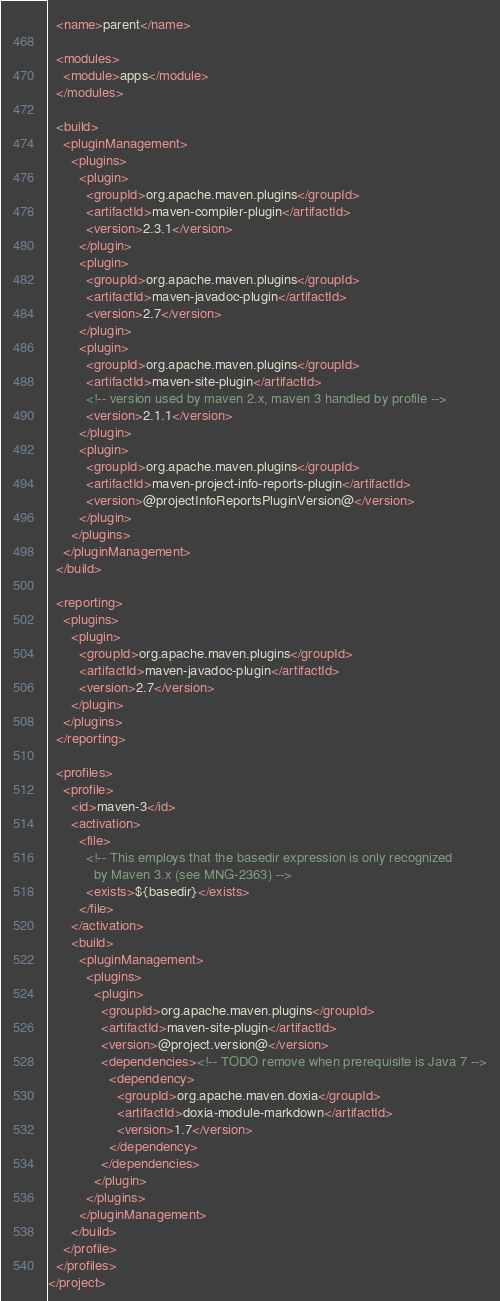<code> <loc_0><loc_0><loc_500><loc_500><_XML_>  <name>parent</name>

  <modules>
    <module>apps</module>
  </modules>

  <build>
    <pluginManagement>
      <plugins>
        <plugin>
          <groupId>org.apache.maven.plugins</groupId>
          <artifactId>maven-compiler-plugin</artifactId>
          <version>2.3.1</version>
        </plugin>
        <plugin>
          <groupId>org.apache.maven.plugins</groupId>
          <artifactId>maven-javadoc-plugin</artifactId>
          <version>2.7</version>
        </plugin>
        <plugin>
          <groupId>org.apache.maven.plugins</groupId>
          <artifactId>maven-site-plugin</artifactId>
          <!-- version used by maven 2.x, maven 3 handled by profile -->
          <version>2.1.1</version>
        </plugin>
        <plugin>
          <groupId>org.apache.maven.plugins</groupId>
          <artifactId>maven-project-info-reports-plugin</artifactId>
          <version>@projectInfoReportsPluginVersion@</version>
        </plugin>
      </plugins>
    </pluginManagement>
  </build>

  <reporting>
    <plugins>
      <plugin>
        <groupId>org.apache.maven.plugins</groupId>
        <artifactId>maven-javadoc-plugin</artifactId>
        <version>2.7</version>
      </plugin>
    </plugins>
  </reporting>

  <profiles>
    <profile>
      <id>maven-3</id>
      <activation>
        <file>
          <!-- This employs that the basedir expression is only recognized 
            by Maven 3.x (see MNG-2363) -->
          <exists>${basedir}</exists>
        </file>
      </activation>
      <build>
        <pluginManagement>
          <plugins>
            <plugin>
              <groupId>org.apache.maven.plugins</groupId>
              <artifactId>maven-site-plugin</artifactId>
              <version>@project.version@</version>
              <dependencies><!-- TODO remove when prerequisite is Java 7 -->
                <dependency>
                  <groupId>org.apache.maven.doxia</groupId>
                  <artifactId>doxia-module-markdown</artifactId>
                  <version>1.7</version>
                </dependency>
              </dependencies>
            </plugin>
          </plugins>
        </pluginManagement>
      </build>
    </profile>
  </profiles>
</project></code> 